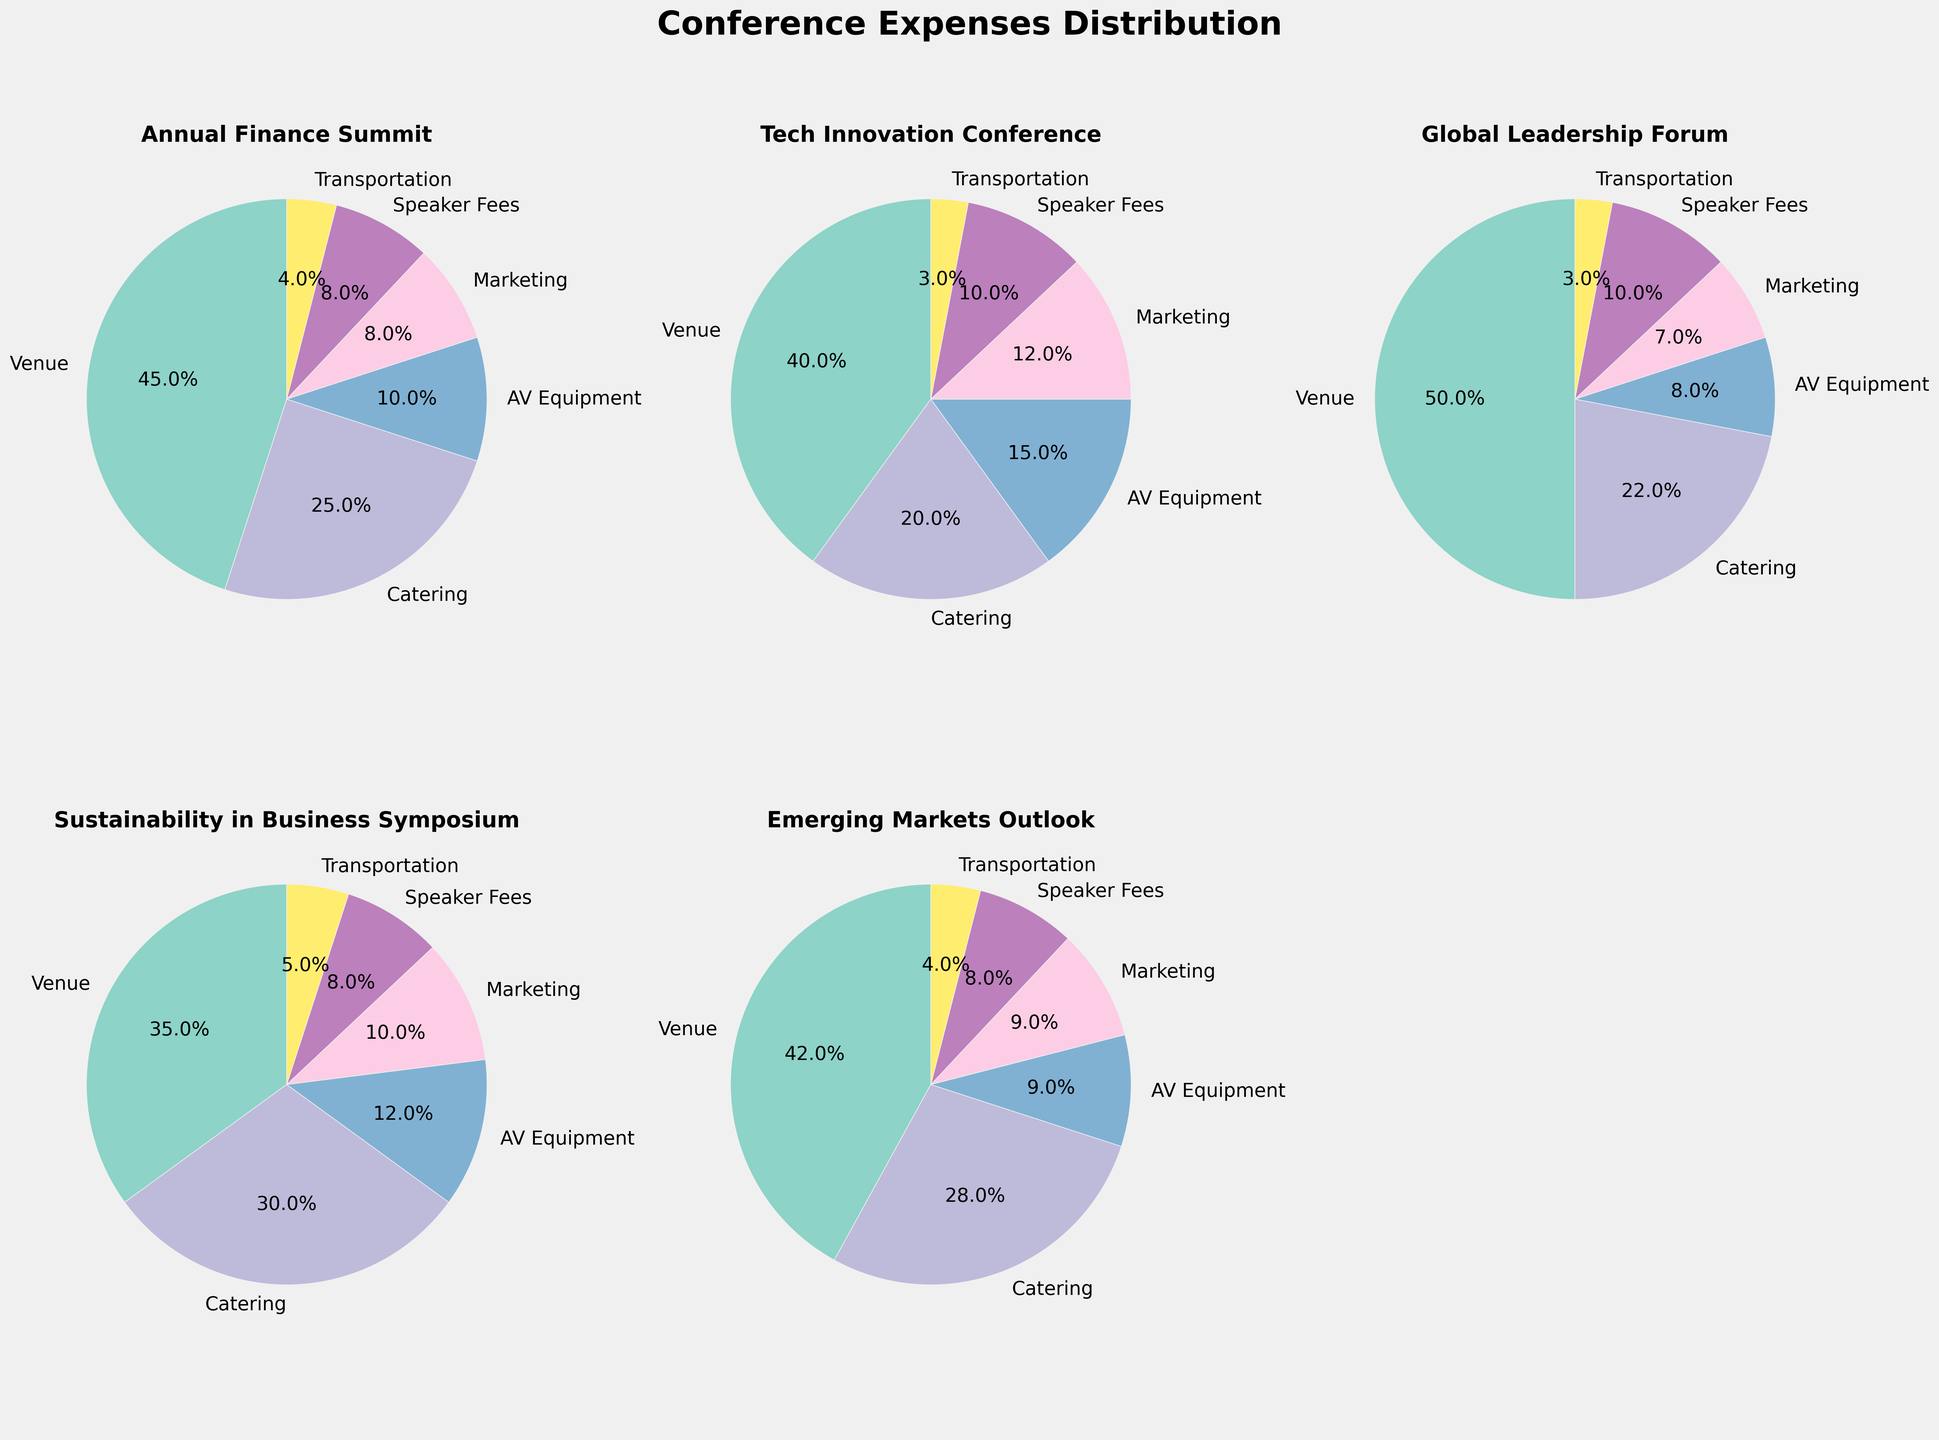Which conference has the highest percentage of its budget spent on venue expenses? By examining the pie charts, observe the segment labeled "Venue" for each conference. The Global Leadership Forum has the largest-seeming segment for "Venue".
Answer: Global Leadership Forum Which two conferences have an equal percentage expenditure on marketing? Look at the pie charts and find the segments labeled "Marketing". Both the Annual Finance Summit and Emerging Markets Outlook each have the "Marketing" segment occupying 8% of their respective charts.
Answer: Annual Finance Summit, Emerging Markets Outlook Which conference spends the least percentage on speaker fees? From the pie charts, check the "Speaker Fees" segment. Both Tech Innovation Conference and Global Leadership Forum have the lowest allocation to "Speaker Fees" at 3%.
Answer: Tech Innovation Conference, Global Leadership Forum Compare the percentage of spending on AV equipment between the Annual Finance Summit and Tech Innovation Conference. Which one spends more? Identify the "AV Equipment" segments in both pie charts. The Tech Innovation Conference has a larger segment for "AV Equipment" at 15%, while the Annual Finance Summit allocates only 10%.
Answer: Tech Innovation Conference How does the transportation expenditure of the Sustainability in Business Symposium compare to that of the Emerging Markets Outlook? Observe the "Transportation" segments. The Sustainability in Business Symposium allocates 5%, while the Emerging Markets Outlook sets aside 4% for transportation. Thus, Sustainability in Business Symposium spends more.
Answer: Sustainability in Business Symposium Which conference has the highest percentage of its budget allotted to catering, and what is that percentage? Look at the "Catering" segments in all pie charts. The Sustainability in Business Symposium has the largest catering segment with 30%.
Answer: Sustainability in Business Symposium, 30% What is the combined expense percentage for marketing and transportation in the Tech Innovation Conference? Locate the respective segments and add their percentages: "Marketing" is 12%, and "Transportation" is 3%. So, the total is 12% + 3% = 15%.
Answer: 15% Which conference spends more on AV equipment than on marketing? Examine the pie charts for the segments "AV Equipment" and "Marketing". For the Tech Innovation Conference, the "AV Equipment" is 15%, and "Marketing" is 12%, which fits the criteria.
Answer: Tech Innovation Conference Compare the percentages allotted to transportation between the Annual Finance Summit and Global Leadership Forum. Look at the "Transportation" segments in both pie charts. Both allocate 4% to transportation.
Answer: Equal (4% each) 